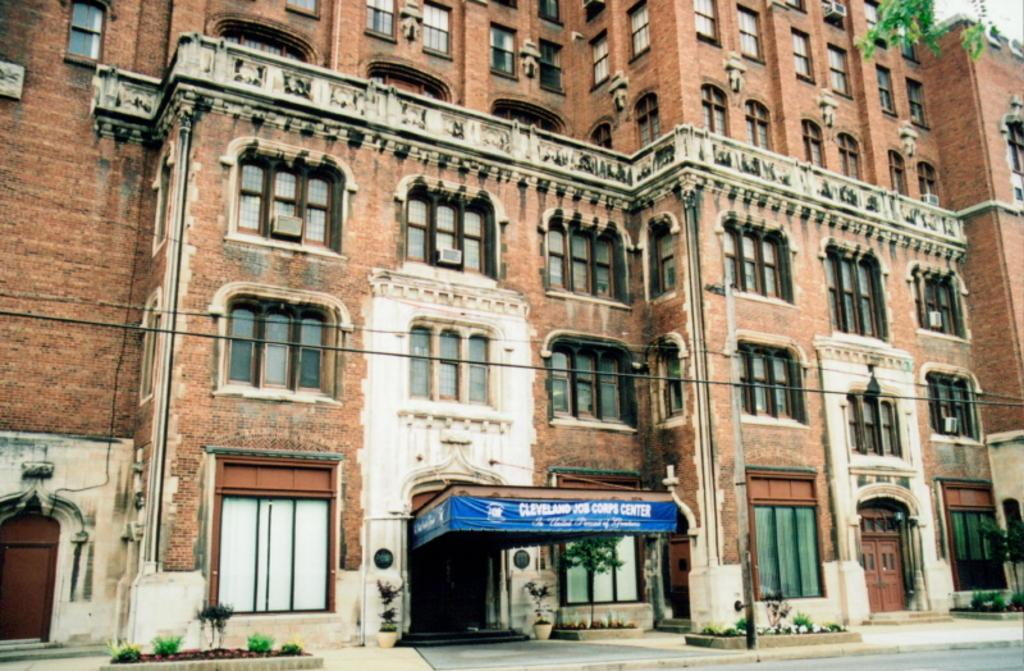What type of structure is visible in the image? There is a building in the image. What features can be seen on the building? The building has windows and doors. What else is present in the image besides the building? There are plants, a pole, wires, stairs, a path, and a road in the image. What color is the ink used to write on the pole in the image? There is no ink or writing present on the pole in the image. How many umbrellas are visible in the image? There are no umbrellas visible in the image. 